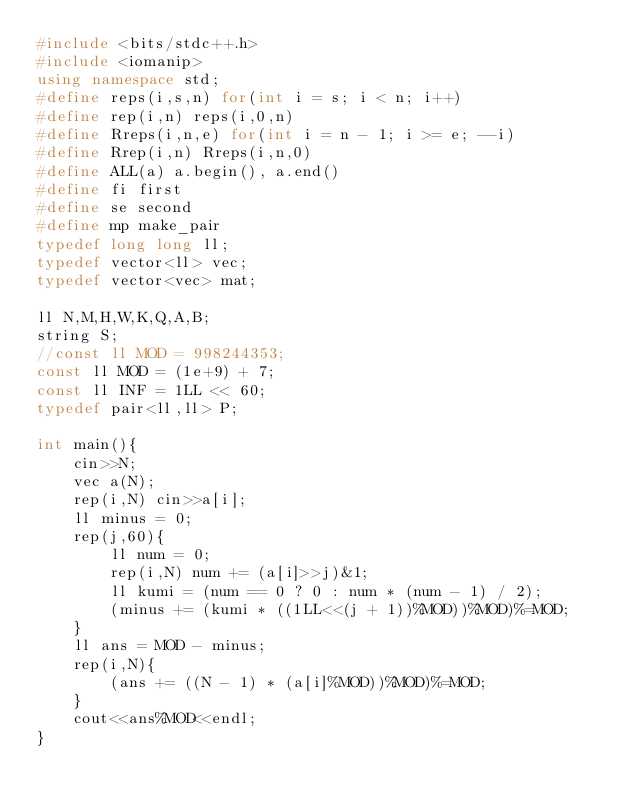<code> <loc_0><loc_0><loc_500><loc_500><_C++_>#include <bits/stdc++.h>
#include <iomanip>
using namespace std;
#define reps(i,s,n) for(int i = s; i < n; i++)
#define rep(i,n) reps(i,0,n)
#define Rreps(i,n,e) for(int i = n - 1; i >= e; --i)
#define Rrep(i,n) Rreps(i,n,0)
#define ALL(a) a.begin(), a.end()
#define fi first
#define se second
#define mp make_pair
typedef long long ll;
typedef vector<ll> vec;
typedef vector<vec> mat;

ll N,M,H,W,K,Q,A,B;
string S;
//const ll MOD = 998244353;
const ll MOD = (1e+9) + 7;
const ll INF = 1LL << 60;
typedef pair<ll,ll> P;

int main(){
    cin>>N;
    vec a(N);
    rep(i,N) cin>>a[i];
    ll minus = 0;
    rep(j,60){
        ll num = 0;
        rep(i,N) num += (a[i]>>j)&1;
        ll kumi = (num == 0 ? 0 : num * (num - 1) / 2);
        (minus += (kumi * ((1LL<<(j + 1))%MOD))%MOD)%=MOD;
    }
    ll ans = MOD - minus;
    rep(i,N){
        (ans += ((N - 1) * (a[i]%MOD))%MOD)%=MOD;
    }
    cout<<ans%MOD<<endl;
}
</code> 